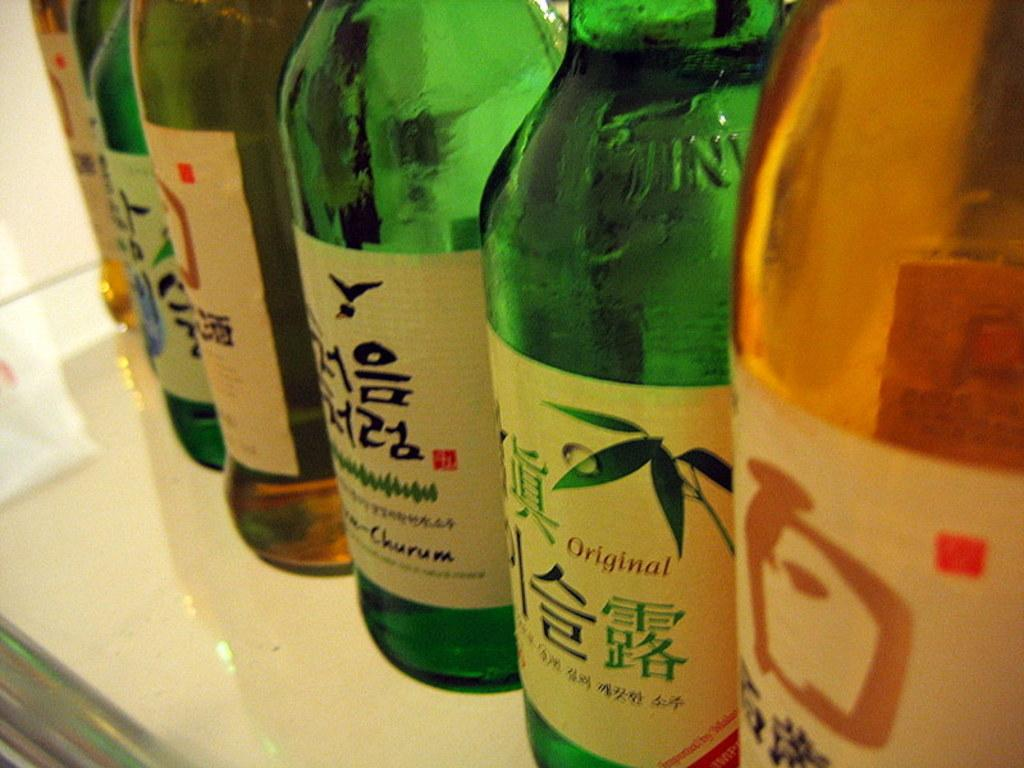What type of table is in the image? There is a white table in the image. What is on the table? There are wine bottles on the table. Can you describe the wine bottles? The wine bottles have labels on them. What type of growth can be seen on the church in the image? There is no church present in the image, so it is not possible to determine if there is any growth on it. 